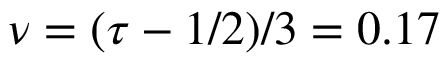Convert formula to latex. <formula><loc_0><loc_0><loc_500><loc_500>\nu = ( \tau - 1 / 2 ) / 3 = 0 . 1 7</formula> 